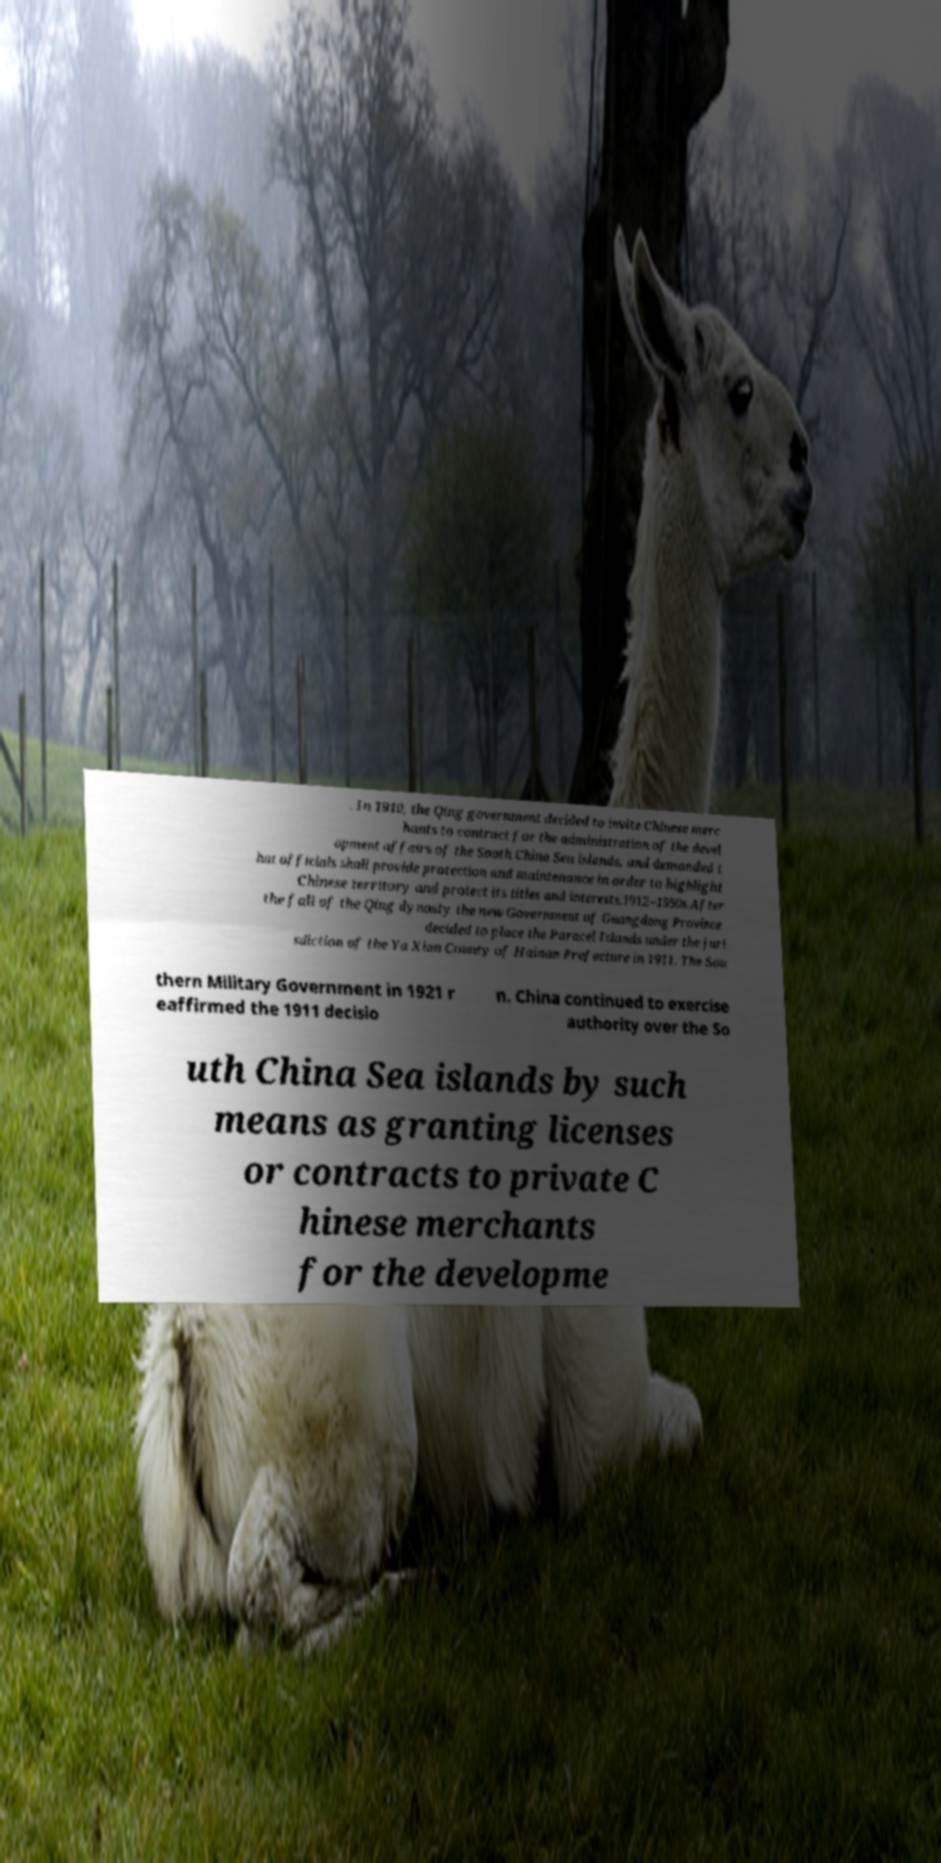Can you accurately transcribe the text from the provided image for me? . In 1910, the Qing government decided to invite Chinese merc hants to contract for the administration of the devel opment affairs of the South China Sea islands, and demanded t hat officials shall provide protection and maintenance in order to highlight Chinese territory and protect its titles and interests.1912–1950s.After the fall of the Qing dynasty the new Government of Guangdong Province decided to place the Paracel Islands under the juri sdiction of the Ya Xian County of Hainan Prefecture in 1911. The Sou thern Military Government in 1921 r eaffirmed the 1911 decisio n. China continued to exercise authority over the So uth China Sea islands by such means as granting licenses or contracts to private C hinese merchants for the developme 